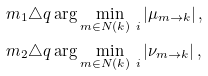<formula> <loc_0><loc_0><loc_500><loc_500>m _ { 1 } & \triangle q \arg \min _ { m \in N ( k ) \ i } \left | \mu _ { m \rightarrow k } \right | , \\ m _ { 2 } & \triangle q \arg \min _ { m \in N ( k ) \ i } \left | \nu _ { m \rightarrow k } \right | ,</formula> 